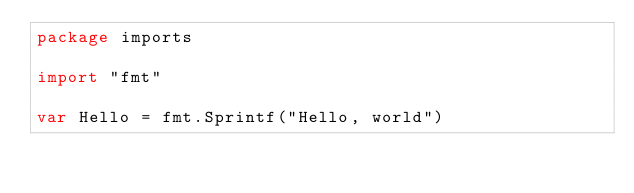Convert code to text. <code><loc_0><loc_0><loc_500><loc_500><_Go_>package imports

import "fmt"

var Hello = fmt.Sprintf("Hello, world")
</code> 